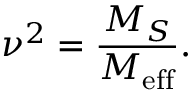<formula> <loc_0><loc_0><loc_500><loc_500>\nu ^ { 2 } = \frac { M _ { S } } { M _ { e f f } } .</formula> 